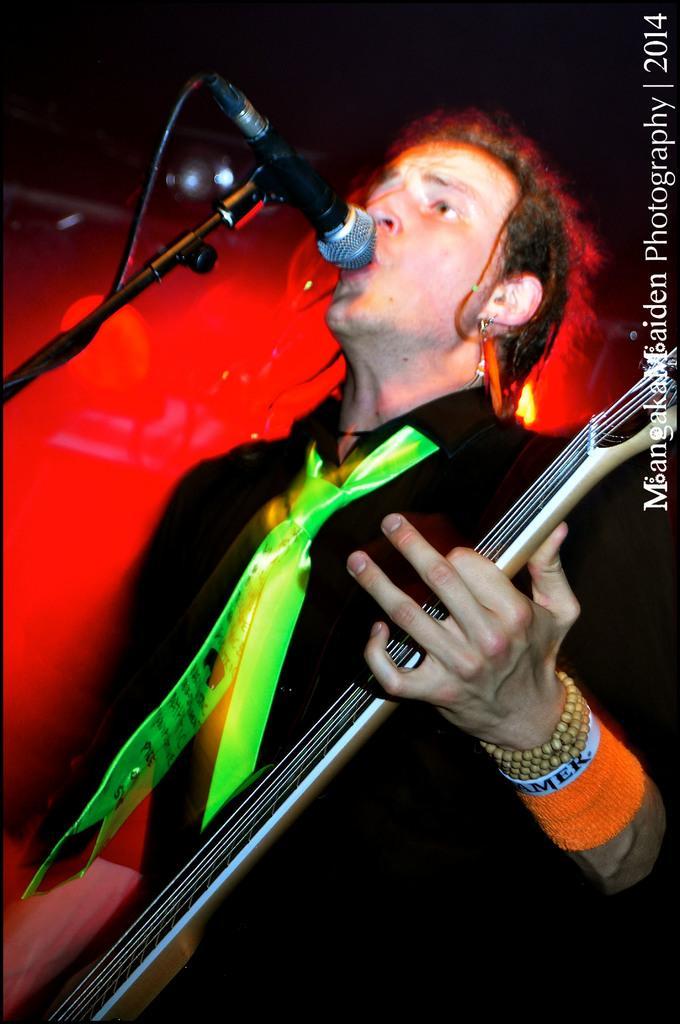Please provide a concise description of this image. In the foreground of this image, there is a man standing in front of a mic stand and holding a guitar and he is wearing a green tie. In the background, there is a red light. 